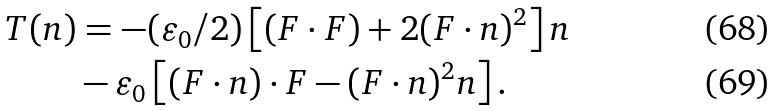Convert formula to latex. <formula><loc_0><loc_0><loc_500><loc_500>T ( n ) & = - ( \varepsilon _ { 0 } / 2 ) \left [ ( F \cdot F ) + 2 ( F \cdot n ) ^ { 2 } \right ] n \\ & - \varepsilon _ { 0 } \left [ ( F \cdot n ) \cdot F - ( F \cdot n ) ^ { 2 } n \right ] .</formula> 